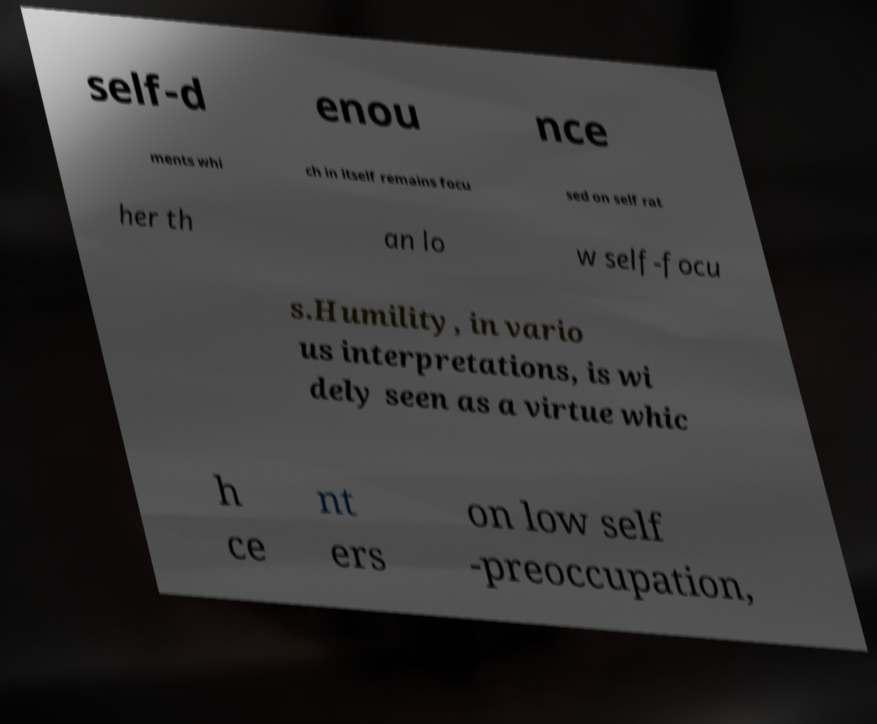Please read and relay the text visible in this image. What does it say? self-d enou nce ments whi ch in itself remains focu sed on self rat her th an lo w self-focu s.Humility, in vario us interpretations, is wi dely seen as a virtue whic h ce nt ers on low self -preoccupation, 